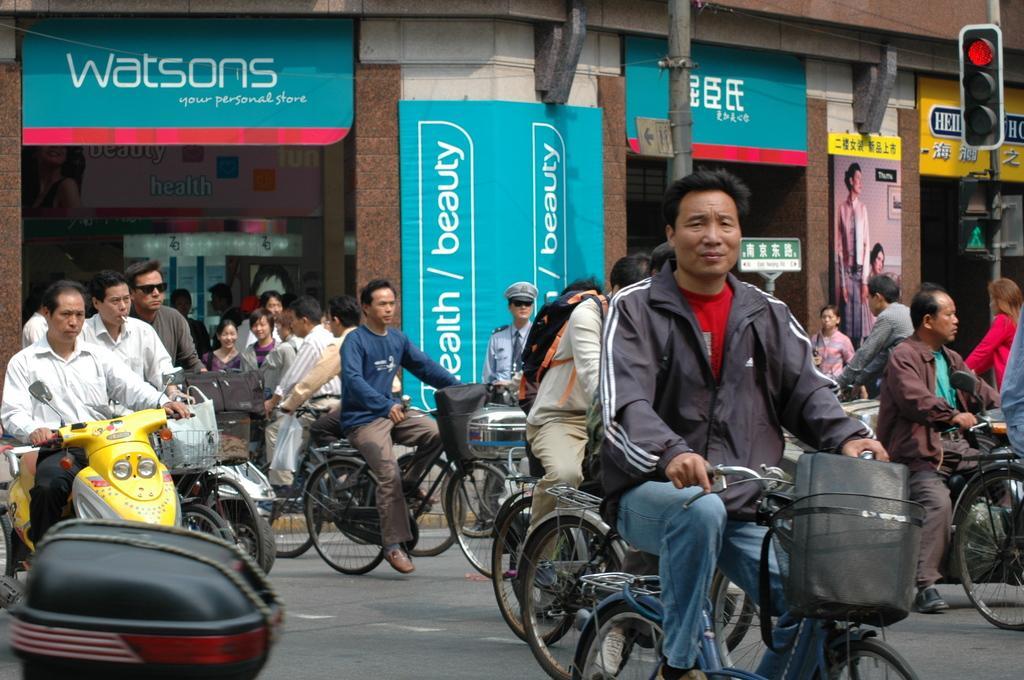How would you summarize this image in a sentence or two? There is a group of people who are riding a bicycle on the road. There is a man riding a motorcycle and he is on the left side. There is a traffic signal pole on the right side. 